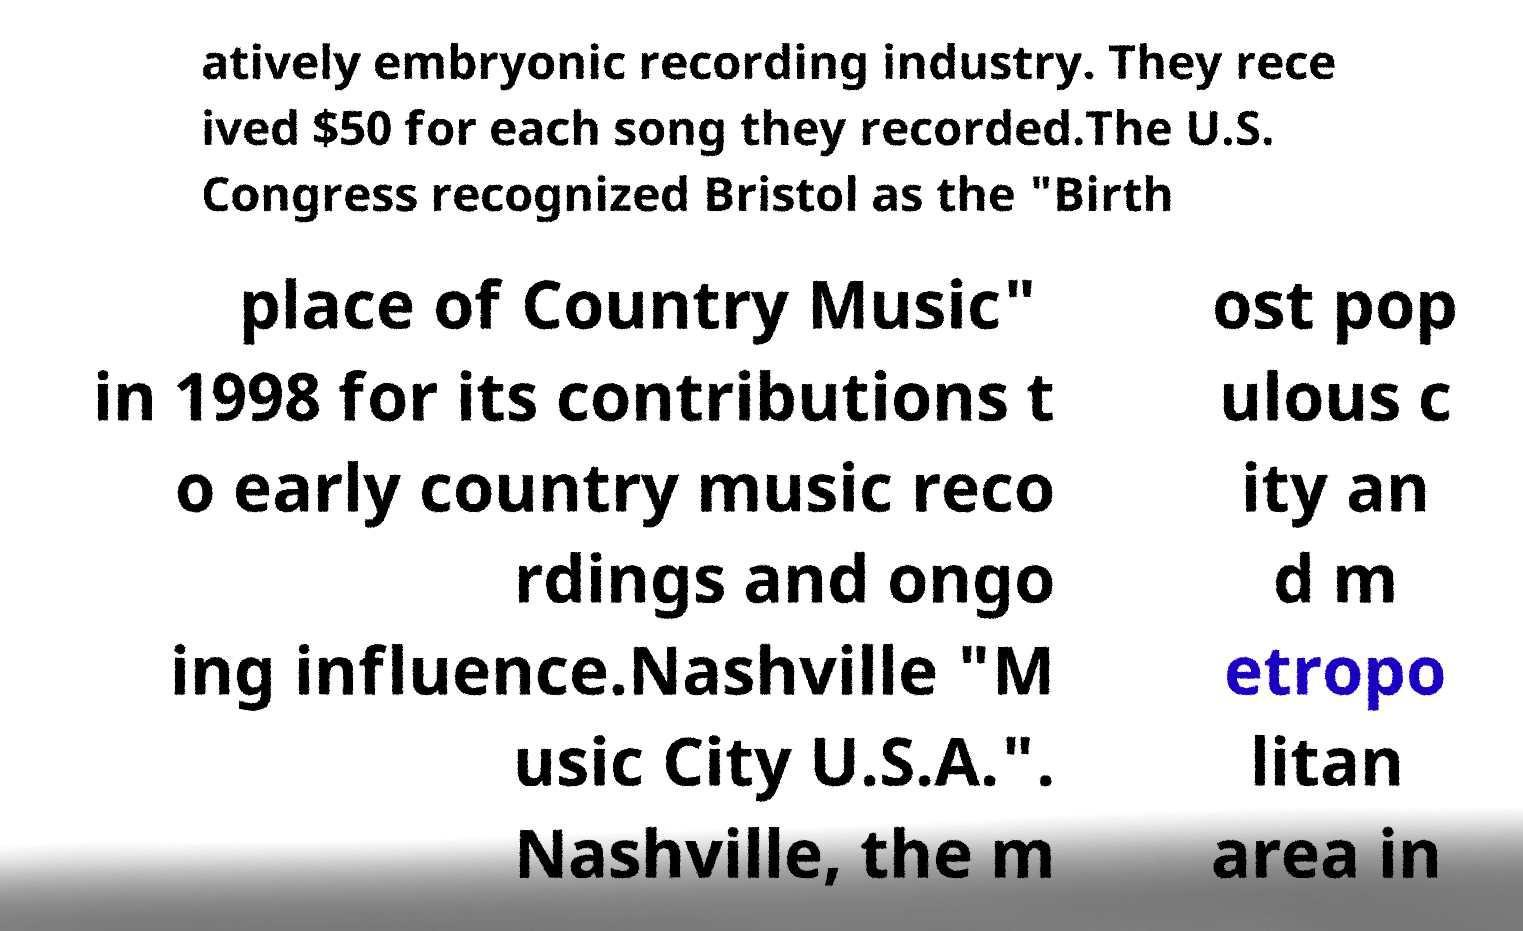I need the written content from this picture converted into text. Can you do that? atively embryonic recording industry. They rece ived $50 for each song they recorded.The U.S. Congress recognized Bristol as the "Birth place of Country Music" in 1998 for its contributions t o early country music reco rdings and ongo ing influence.Nashville "M usic City U.S.A.". Nashville, the m ost pop ulous c ity an d m etropo litan area in 